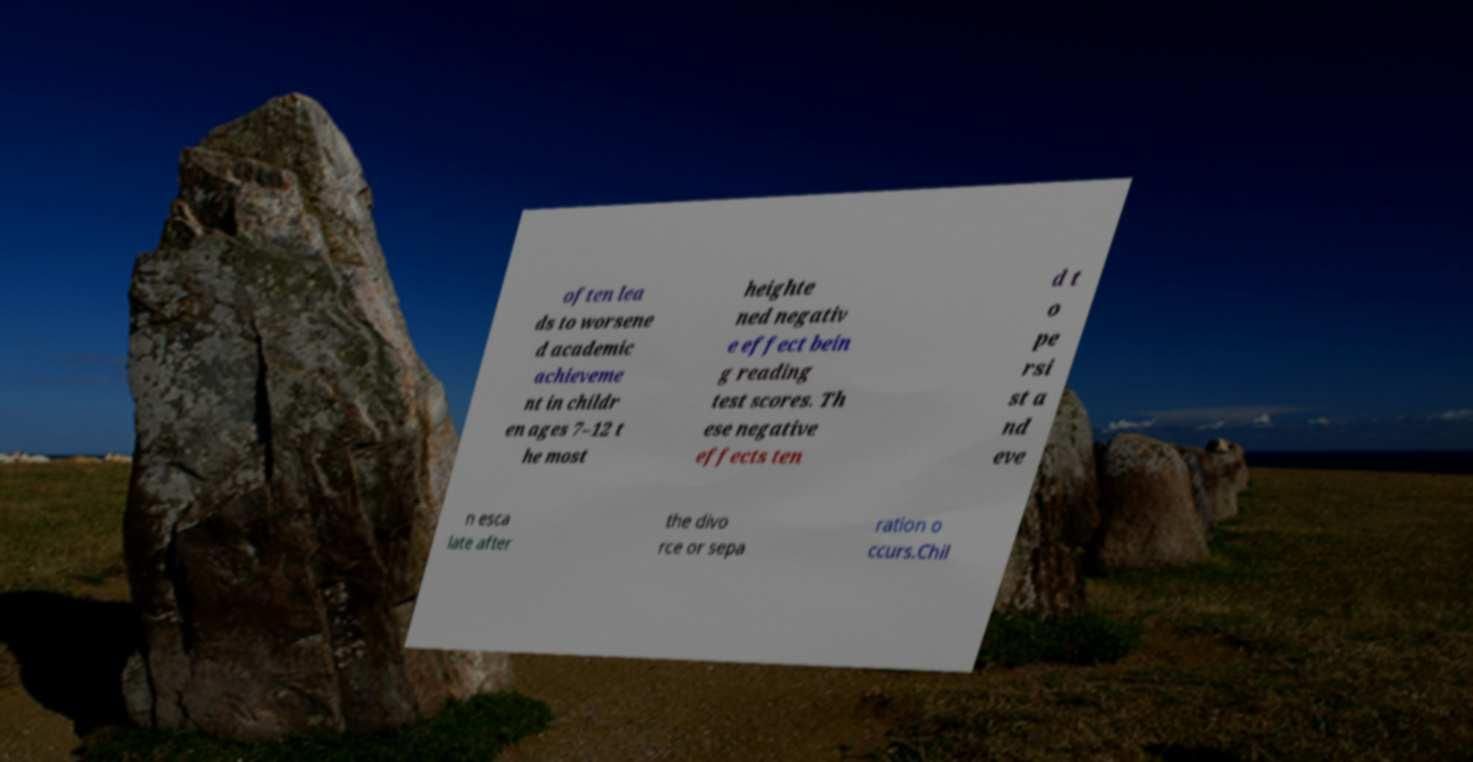Can you accurately transcribe the text from the provided image for me? often lea ds to worsene d academic achieveme nt in childr en ages 7–12 t he most heighte ned negativ e effect bein g reading test scores. Th ese negative effects ten d t o pe rsi st a nd eve n esca late after the divo rce or sepa ration o ccurs.Chil 